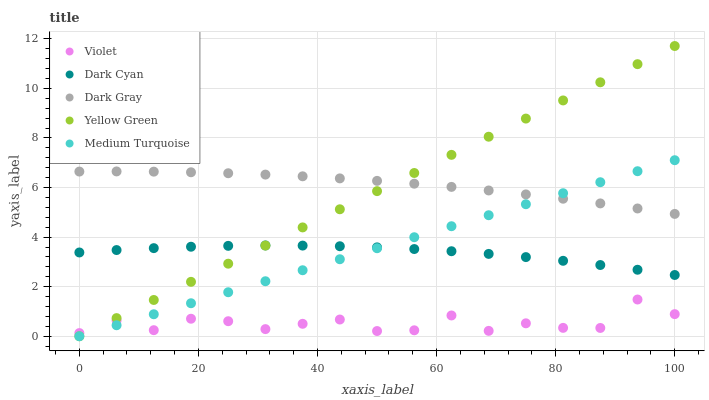Does Violet have the minimum area under the curve?
Answer yes or no. Yes. Does Dark Gray have the maximum area under the curve?
Answer yes or no. Yes. Does Yellow Green have the minimum area under the curve?
Answer yes or no. No. Does Yellow Green have the maximum area under the curve?
Answer yes or no. No. Is Medium Turquoise the smoothest?
Answer yes or no. Yes. Is Violet the roughest?
Answer yes or no. Yes. Is Dark Gray the smoothest?
Answer yes or no. No. Is Dark Gray the roughest?
Answer yes or no. No. Does Yellow Green have the lowest value?
Answer yes or no. Yes. Does Dark Gray have the lowest value?
Answer yes or no. No. Does Yellow Green have the highest value?
Answer yes or no. Yes. Does Dark Gray have the highest value?
Answer yes or no. No. Is Dark Cyan less than Dark Gray?
Answer yes or no. Yes. Is Dark Cyan greater than Violet?
Answer yes or no. Yes. Does Yellow Green intersect Dark Cyan?
Answer yes or no. Yes. Is Yellow Green less than Dark Cyan?
Answer yes or no. No. Is Yellow Green greater than Dark Cyan?
Answer yes or no. No. Does Dark Cyan intersect Dark Gray?
Answer yes or no. No. 